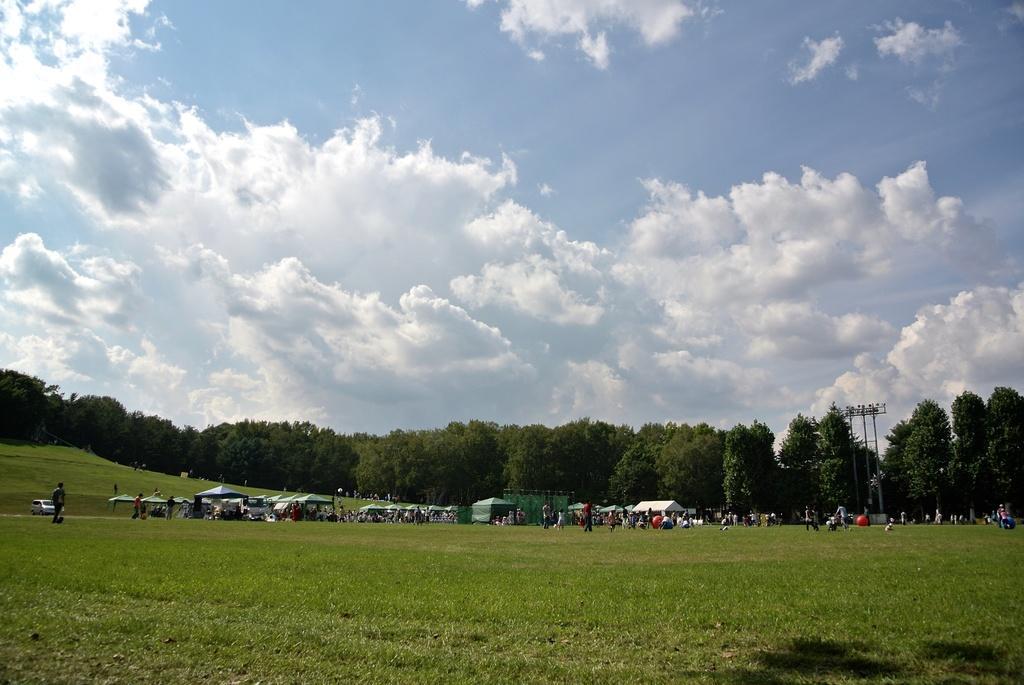Can you describe this image briefly? In this image we can see a group of people, some balls, tents, vehicles and some poles on the ground. We can also see some grass, a group of trees and the sky which looks cloudy. 